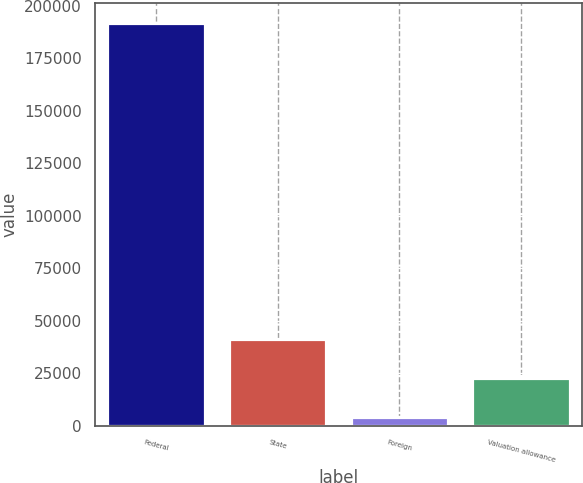Convert chart to OTSL. <chart><loc_0><loc_0><loc_500><loc_500><bar_chart><fcel>Federal<fcel>State<fcel>Foreign<fcel>Valuation allowance<nl><fcel>191596<fcel>41560.8<fcel>4052<fcel>22806.4<nl></chart> 